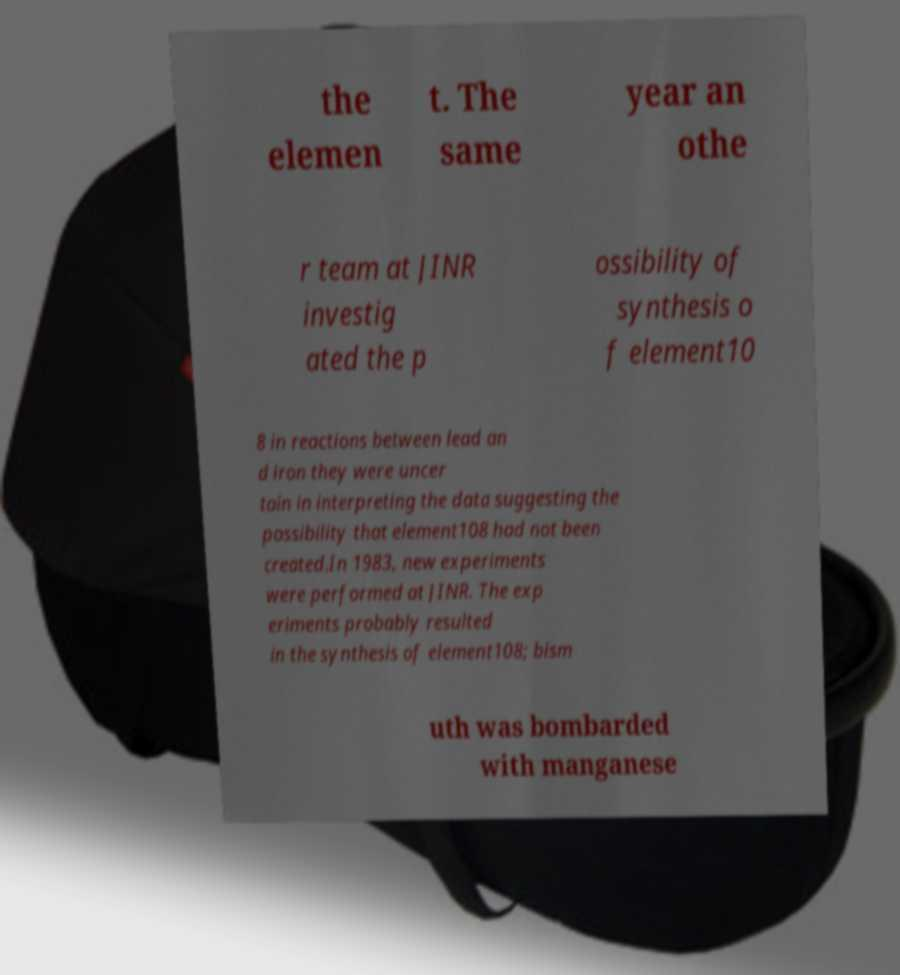I need the written content from this picture converted into text. Can you do that? the elemen t. The same year an othe r team at JINR investig ated the p ossibility of synthesis o f element10 8 in reactions between lead an d iron they were uncer tain in interpreting the data suggesting the possibility that element108 had not been created.In 1983, new experiments were performed at JINR. The exp eriments probably resulted in the synthesis of element108; bism uth was bombarded with manganese 